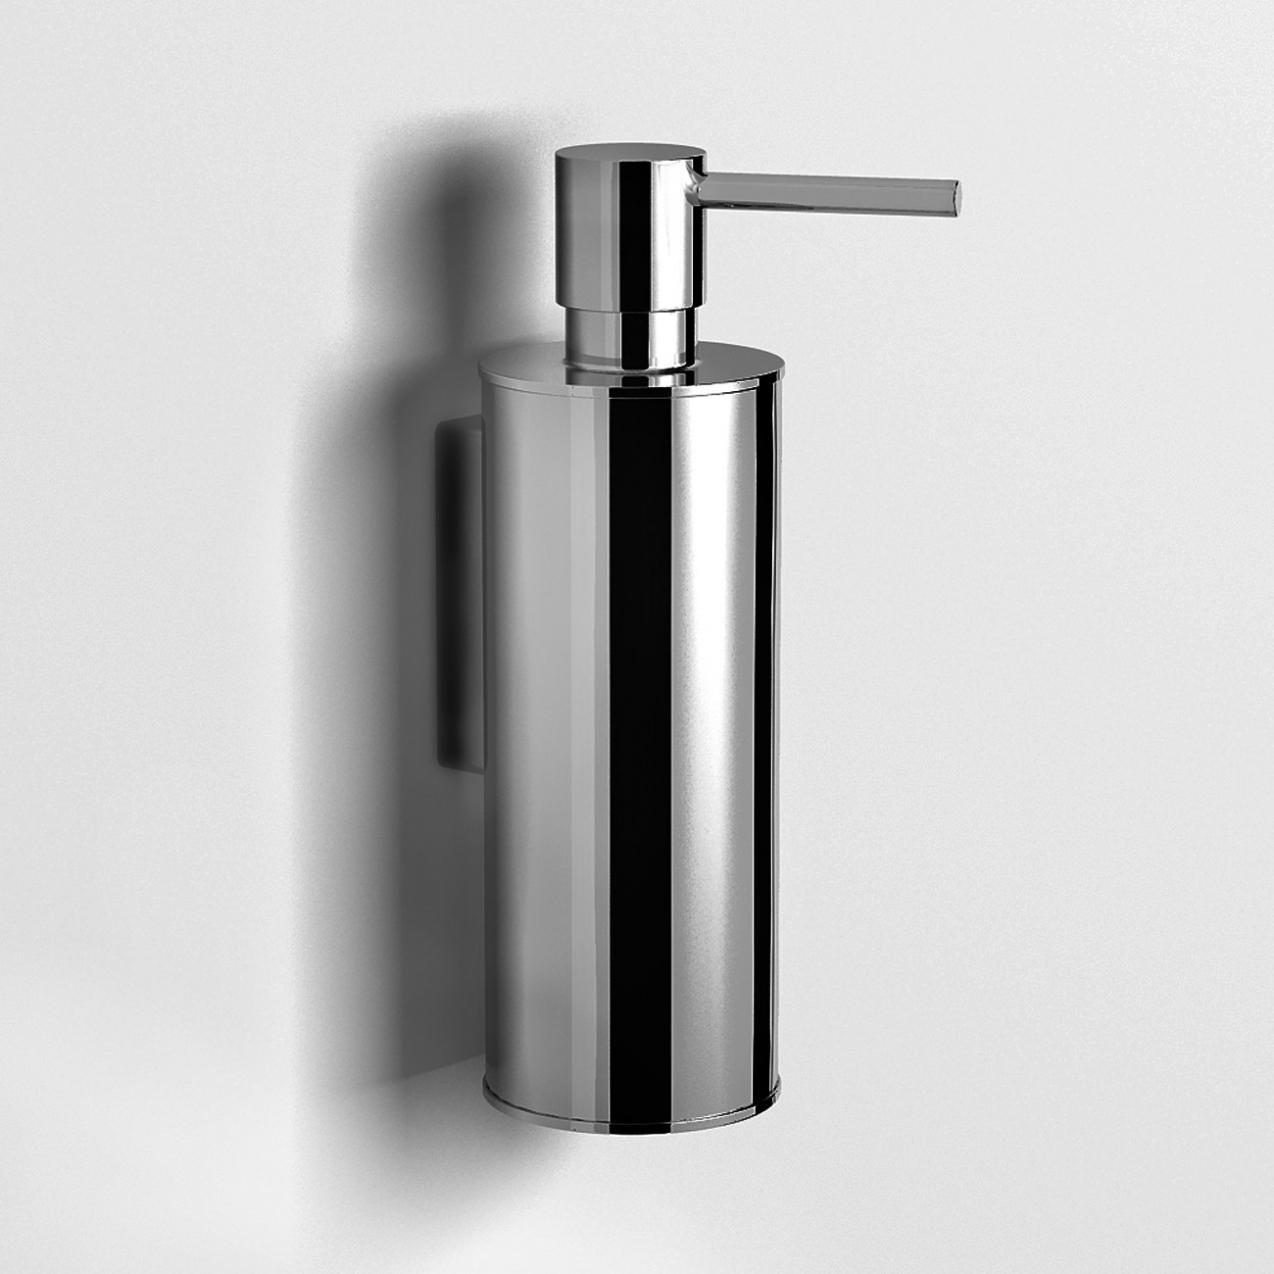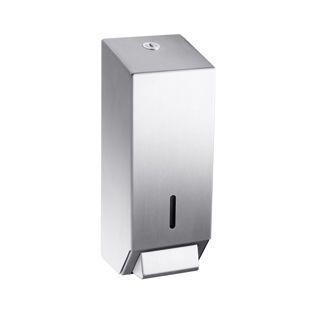The first image is the image on the left, the second image is the image on the right. For the images displayed, is the sentence "There is exactly one white dispenser." factually correct? Answer yes or no. No. The first image is the image on the left, the second image is the image on the right. Analyze the images presented: Is the assertion "One of the soap dispensers is significantly darker than the other." valid? Answer yes or no. No. 